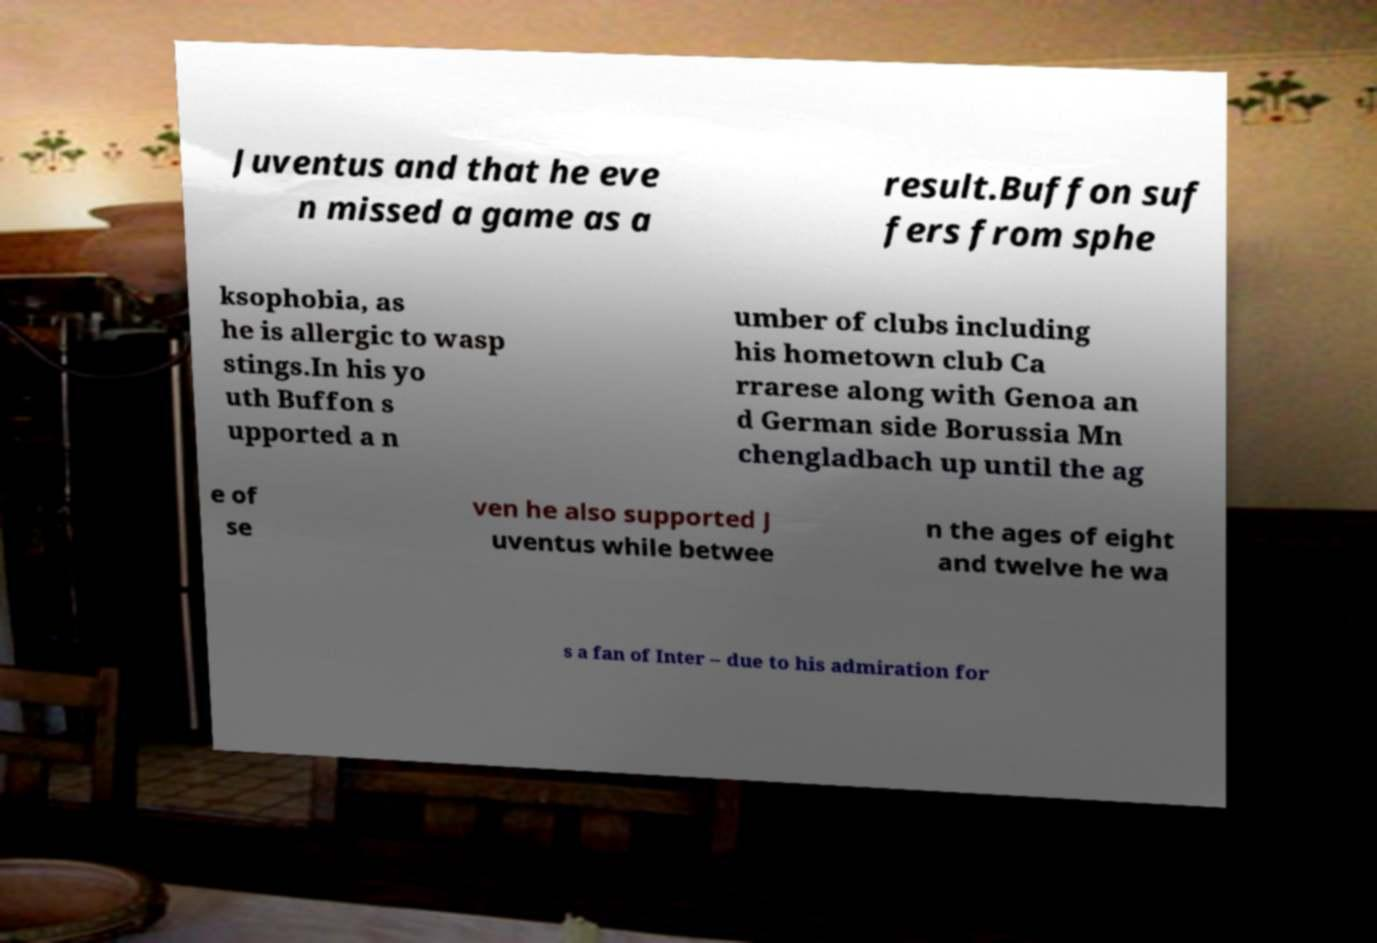Could you extract and type out the text from this image? Juventus and that he eve n missed a game as a result.Buffon suf fers from sphe ksophobia, as he is allergic to wasp stings.In his yo uth Buffon s upported a n umber of clubs including his hometown club Ca rrarese along with Genoa an d German side Borussia Mn chengladbach up until the ag e of se ven he also supported J uventus while betwee n the ages of eight and twelve he wa s a fan of Inter – due to his admiration for 